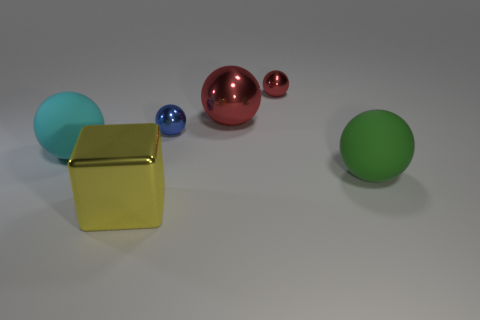How many small red balls are to the left of the big rubber ball in front of the matte sphere that is behind the big green matte thing?
Your response must be concise. 1. What material is the cyan ball that is the same size as the green matte object?
Keep it short and to the point. Rubber. Is there a yellow thing that has the same size as the cyan rubber ball?
Provide a succinct answer. Yes. What color is the shiny cube?
Ensure brevity in your answer.  Yellow. There is a large matte object that is to the left of the thing that is in front of the green sphere; what color is it?
Offer a terse response. Cyan. There is a large matte object that is in front of the big rubber thing behind the big rubber thing that is to the right of the blue object; what is its shape?
Your answer should be compact. Sphere. How many other spheres have the same material as the blue sphere?
Ensure brevity in your answer.  2. How many big balls are to the left of the big rubber object that is to the right of the blue metal thing?
Provide a succinct answer. 2. How many yellow shiny cubes are there?
Provide a succinct answer. 1. Do the blue thing and the large sphere that is behind the large cyan matte sphere have the same material?
Your answer should be very brief. Yes. 